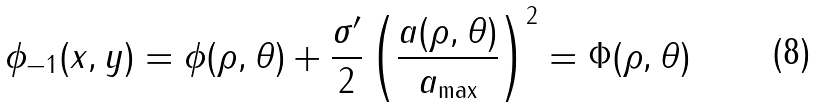Convert formula to latex. <formula><loc_0><loc_0><loc_500><loc_500>\phi _ { - 1 } ( x , y ) = \phi ( \rho , \theta ) + \frac { \sigma ^ { \prime } } { 2 } \left ( \frac { a ( \rho , \theta ) } { a _ { \max } } \right ) ^ { 2 } = \Phi ( \rho , \theta )</formula> 